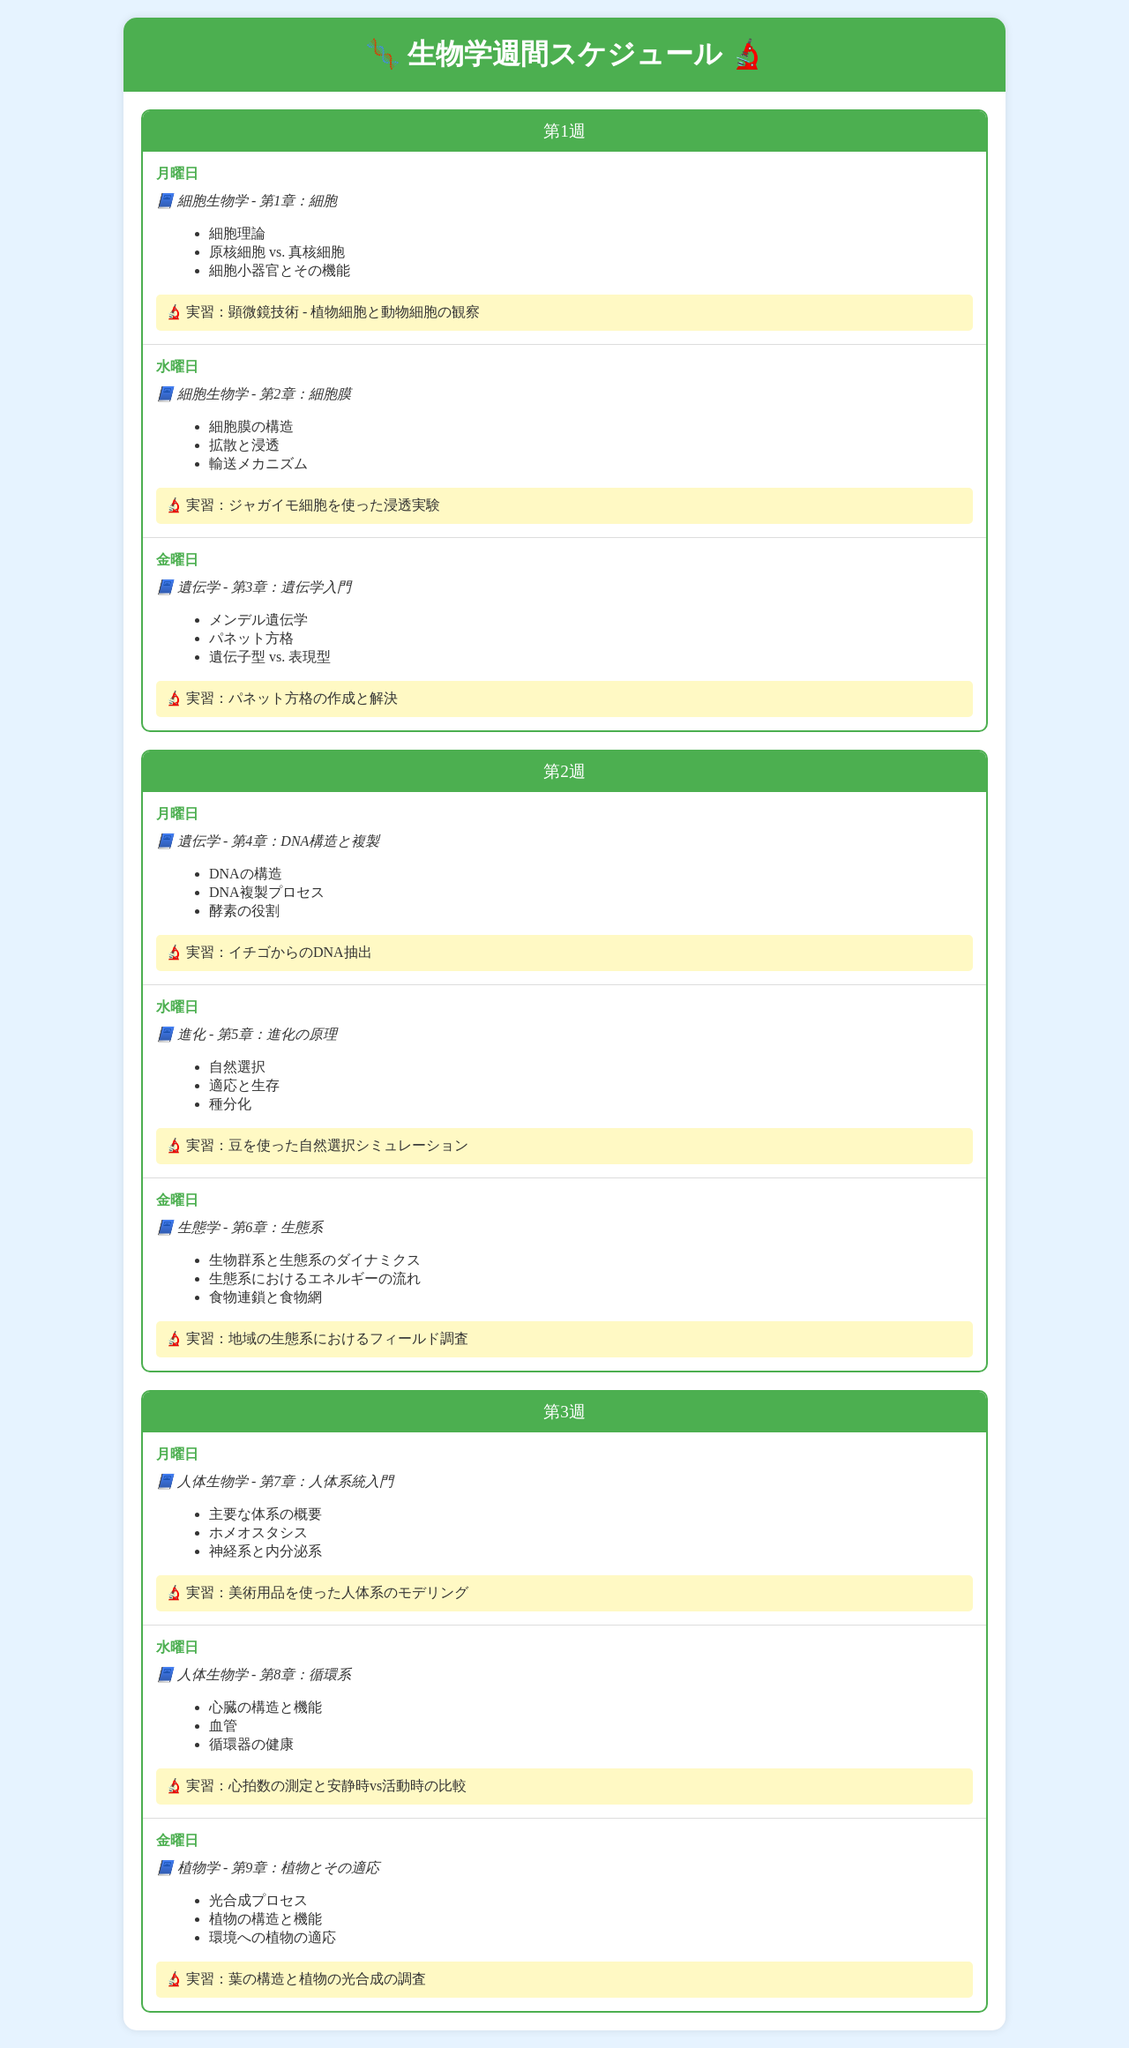What chapter is covered on Monday of Week 1? The document specifies that Monday of Week 1 covers Chapter 1 of Cell Biology.
Answer: 第1章：細胞 What is one key concept from Chapter 2 in Week 1? The document lists several key concepts for Chapter 2 of Cell Biology; one of them is provided.
Answer: 拡散と浸透 Which practical lab session is scheduled for Friday of Week 2? The practical lab session scheduled for Friday of Week 2 focuses on creating and solving a Punnett square.
Answer: パネット方格の作成と解決 How many chapters are covered in Week 3? The document states that there are three chapters covered in Week 3, with each day focusing on a different chapter.
Answer: 3 What is the title of Chapter 4 in Week 2? According to the document, Chapter 4 in Week 2 focuses on the structure and replication of DNA.
Answer: DNA構造と複製 Which week includes a lab session on heart rate measurement? Week 3 includes a lab session focused on measuring heart rate and comparing resting versus active rates.
Answer: 第3週 What key concept from Chapter 8 relates to the circulatory system? The document mentions several key concepts; one includes the structure and function of the heart relevant to Chapter 8.
Answer: 心臓の構造と機能 What practical lab session is done on Monday of Week 1? The document specifies that on Monday of Week 1, the practical lab session involves microscope techniques.
Answer: 顕微鏡技術 - 植物細胞と動物細胞の観察 